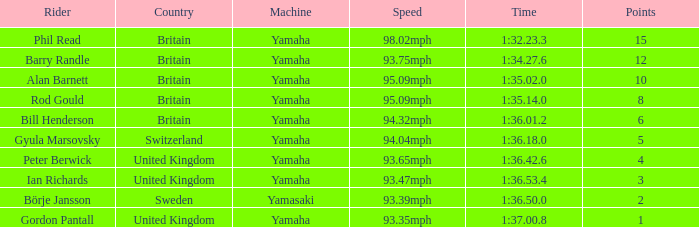What was the time for the man who scored 1 point? 1:37.00.8. 